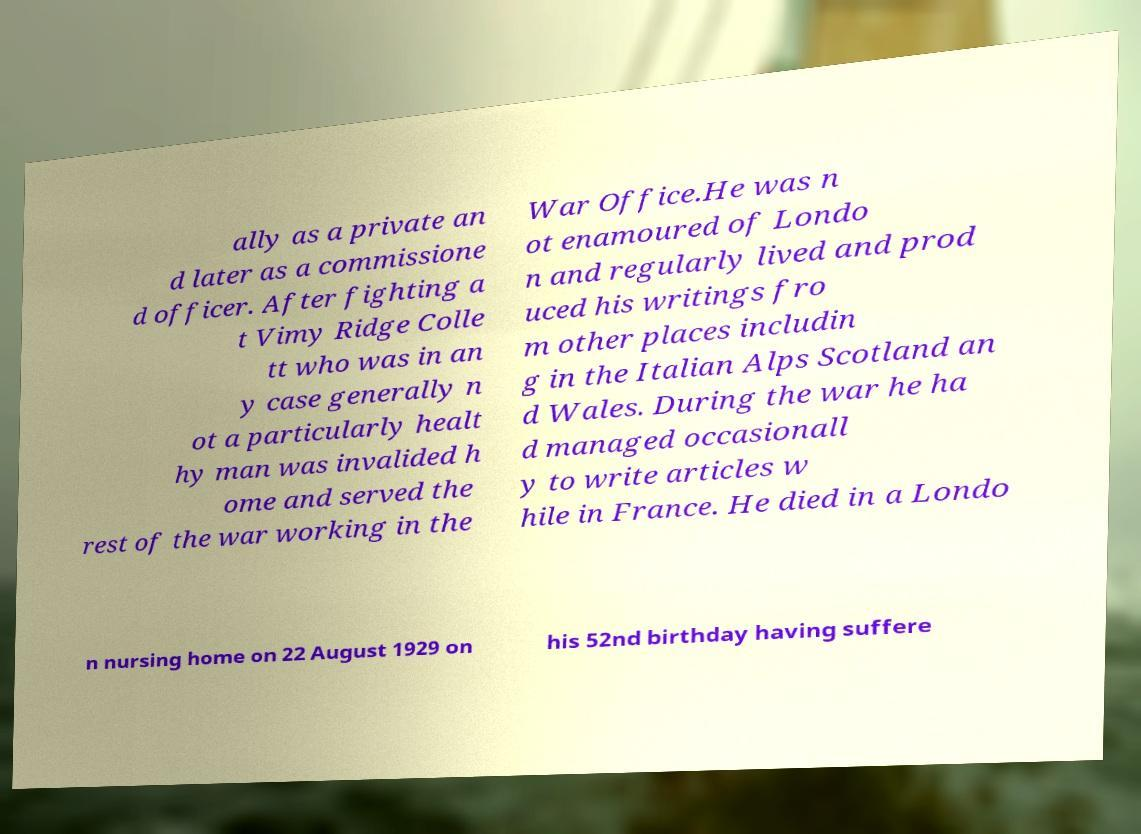Please identify and transcribe the text found in this image. ally as a private an d later as a commissione d officer. After fighting a t Vimy Ridge Colle tt who was in an y case generally n ot a particularly healt hy man was invalided h ome and served the rest of the war working in the War Office.He was n ot enamoured of Londo n and regularly lived and prod uced his writings fro m other places includin g in the Italian Alps Scotland an d Wales. During the war he ha d managed occasionall y to write articles w hile in France. He died in a Londo n nursing home on 22 August 1929 on his 52nd birthday having suffere 